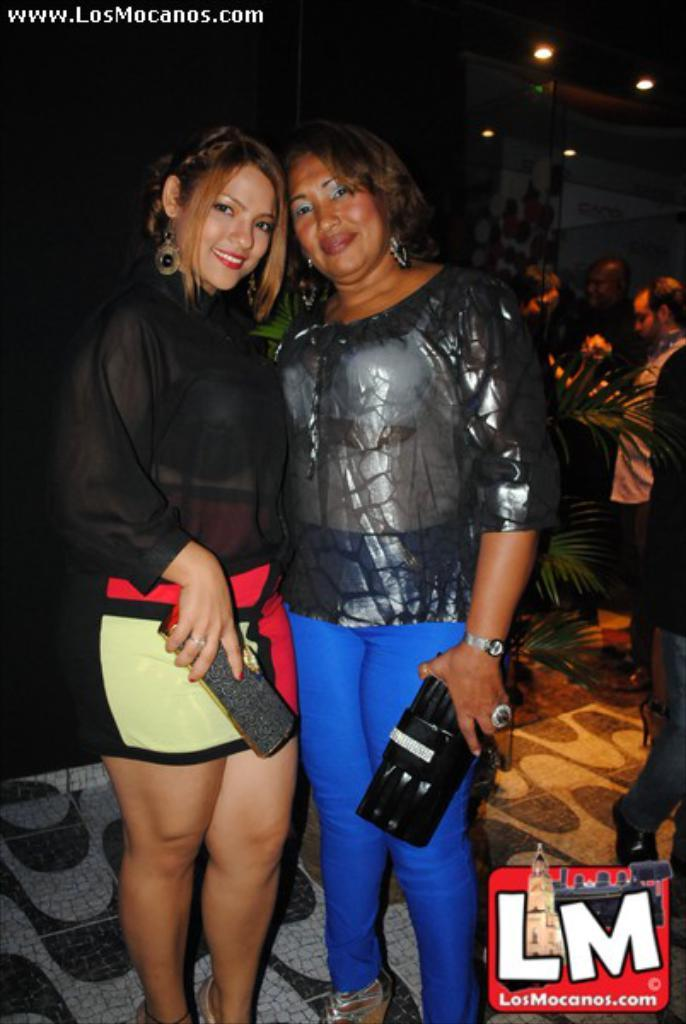Who is in the front of the image? There are women standing in the front of the image. What are the women doing in the image? The women are smiling. What can be seen in the background of the image? There are persons standing in the background of the image, as well as a plant. What is located at the top of the image? There are lights on the top of the image. What book is the woman holding in the image? There is no book visible in the image; the women are not holding any books. How many matches are on the ground in the image? There are no matches present in the image. 